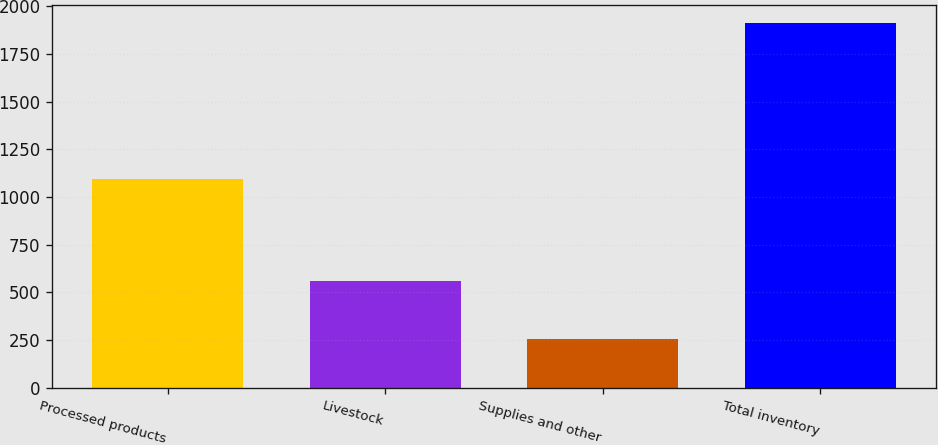<chart> <loc_0><loc_0><loc_500><loc_500><bar_chart><fcel>Processed products<fcel>Livestock<fcel>Supplies and other<fcel>Total inventory<nl><fcel>1095<fcel>561<fcel>255<fcel>1911<nl></chart> 